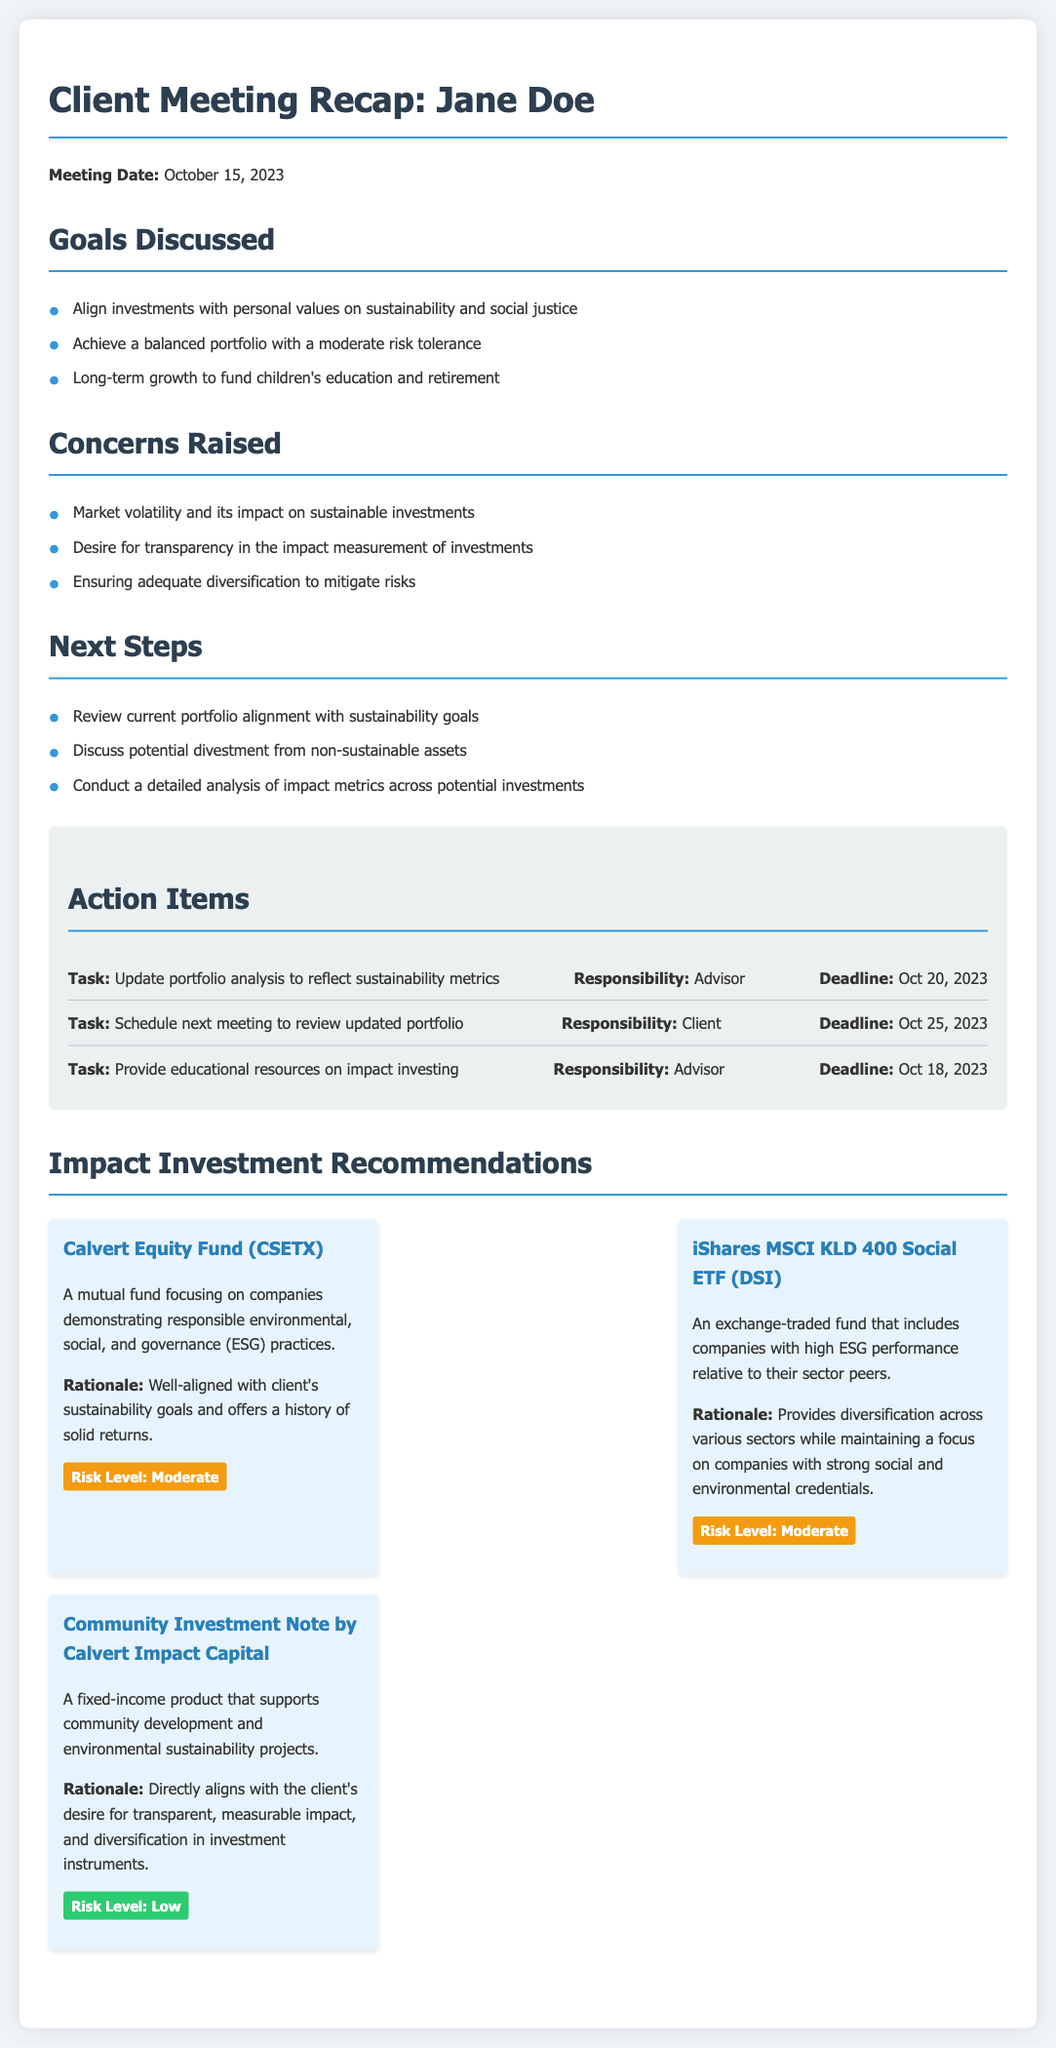What is the meeting date? The meeting date is explicitly stated in the document as October 15, 2023.
Answer: October 15, 2023 What is one of the goals discussed? The document lists goals under the "Goals Discussed" section; one example is "Align investments with personal values on sustainability and social justice."
Answer: Align investments with personal values on sustainability and social justice Who is responsible for updating the portfolio analysis? In the action items section, the responsibility for updating the portfolio analysis is assigned to the advisor.
Answer: Advisor What is the risk level of the Community Investment Note by Calvert Impact Capital? The document specifies the risk level of each investment recommendation; for the Community Investment Note, it is labeled as "Low."
Answer: Low What educational resources are to be provided? It is stated in the action items that the advisor will provide "educational resources on impact investing."
Answer: Educational resources on impact investing What concern was raised about market conditions? One of the concerns mentioned about market conditions is "Market volatility and its impact on sustainable investments."
Answer: Market volatility and its impact on sustainable investments What is the rationale for recommending the Calvert Equity Fund? The rationale for the Calvert Equity Fund is outlined as being "Well-aligned with client's sustainability goals and offers a history of solid returns."
Answer: Well-aligned with client's sustainability goals and offers a history of solid returns When is the next meeting scheduled to review the updated portfolio? The deadline set for scheduling the next meeting is October 25, 2023.
Answer: October 25, 2023 How many investment recommendations are provided? The document contains three distinct investment recommendations listed under the "Impact Investment Recommendations" section.
Answer: Three 